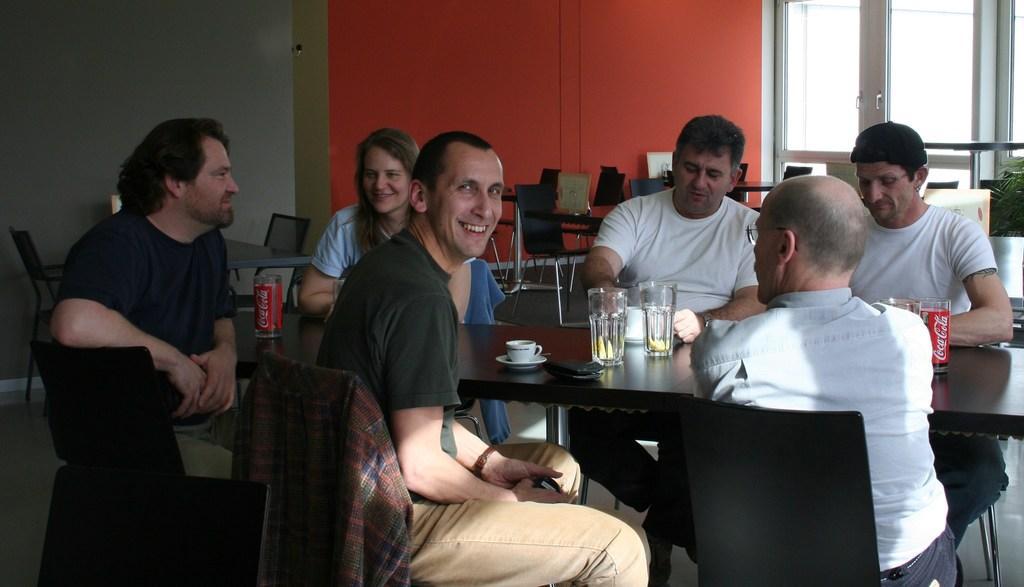Describe this image in one or two sentences. In this image there are few people who are sitting on chair and around the table. On the table there are two glasses,cup,purse and a cool drink tin. At the back side there are chairs,wall and the door. 